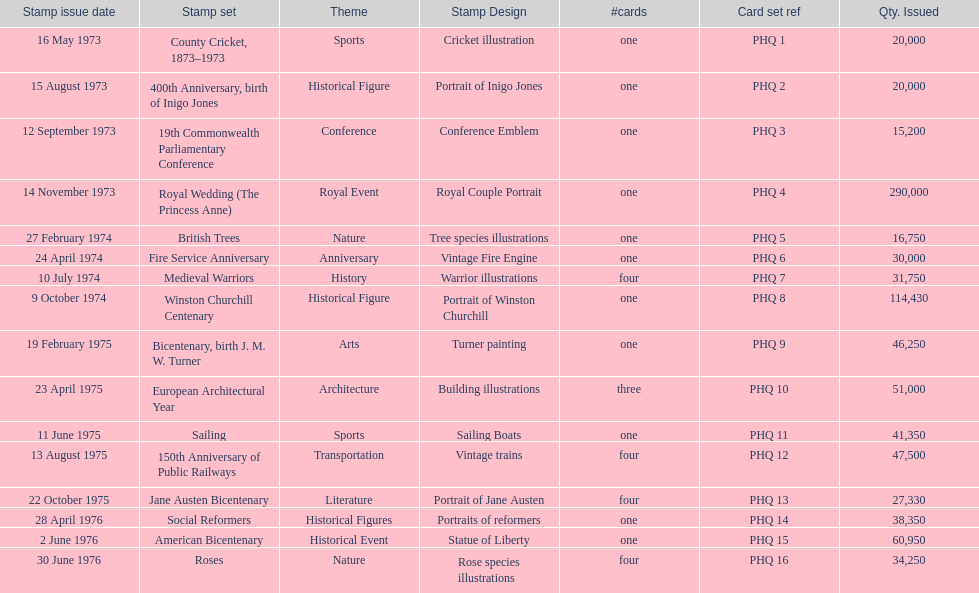List each bicentenary stamp set Bicentenary, birth J. M. W. Turner, Jane Austen Bicentenary, American Bicentenary. 